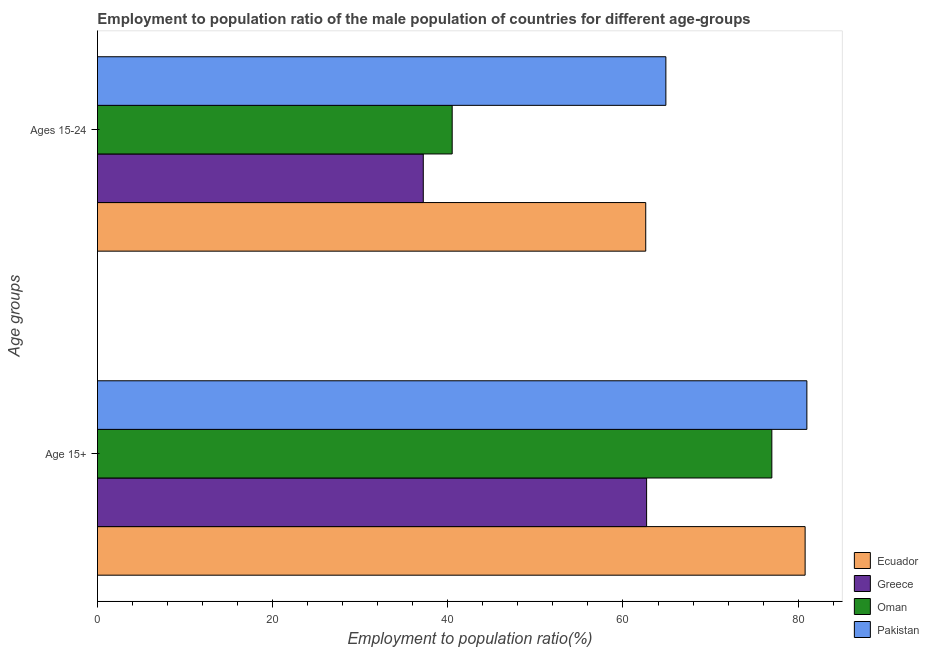Are the number of bars per tick equal to the number of legend labels?
Offer a very short reply. Yes. How many bars are there on the 1st tick from the top?
Ensure brevity in your answer.  4. How many bars are there on the 1st tick from the bottom?
Offer a terse response. 4. What is the label of the 2nd group of bars from the top?
Provide a short and direct response. Age 15+. What is the employment to population ratio(age 15+) in Greece?
Offer a very short reply. 62.7. Across all countries, what is the maximum employment to population ratio(age 15-24)?
Ensure brevity in your answer.  64.9. Across all countries, what is the minimum employment to population ratio(age 15-24)?
Make the answer very short. 37.2. In which country was the employment to population ratio(age 15-24) maximum?
Your answer should be very brief. Pakistan. In which country was the employment to population ratio(age 15+) minimum?
Offer a very short reply. Greece. What is the total employment to population ratio(age 15-24) in the graph?
Make the answer very short. 205.2. What is the difference between the employment to population ratio(age 15+) in Oman and that in Greece?
Your answer should be compact. 14.3. What is the difference between the employment to population ratio(age 15-24) in Ecuador and the employment to population ratio(age 15+) in Pakistan?
Your response must be concise. -18.4. What is the average employment to population ratio(age 15-24) per country?
Keep it short and to the point. 51.3. What is the difference between the employment to population ratio(age 15+) and employment to population ratio(age 15-24) in Oman?
Your answer should be very brief. 36.5. In how many countries, is the employment to population ratio(age 15+) greater than 40 %?
Offer a terse response. 4. What is the ratio of the employment to population ratio(age 15-24) in Ecuador to that in Greece?
Give a very brief answer. 1.68. Is the employment to population ratio(age 15+) in Oman less than that in Ecuador?
Offer a very short reply. Yes. In how many countries, is the employment to population ratio(age 15-24) greater than the average employment to population ratio(age 15-24) taken over all countries?
Offer a very short reply. 2. Are all the bars in the graph horizontal?
Your answer should be compact. Yes. How many countries are there in the graph?
Offer a terse response. 4. Are the values on the major ticks of X-axis written in scientific E-notation?
Your response must be concise. No. Does the graph contain any zero values?
Offer a terse response. No. Does the graph contain grids?
Your response must be concise. No. What is the title of the graph?
Your response must be concise. Employment to population ratio of the male population of countries for different age-groups. Does "High income: nonOECD" appear as one of the legend labels in the graph?
Offer a terse response. No. What is the label or title of the X-axis?
Give a very brief answer. Employment to population ratio(%). What is the label or title of the Y-axis?
Your answer should be very brief. Age groups. What is the Employment to population ratio(%) of Ecuador in Age 15+?
Ensure brevity in your answer.  80.8. What is the Employment to population ratio(%) in Greece in Age 15+?
Ensure brevity in your answer.  62.7. What is the Employment to population ratio(%) of Ecuador in Ages 15-24?
Give a very brief answer. 62.6. What is the Employment to population ratio(%) in Greece in Ages 15-24?
Provide a short and direct response. 37.2. What is the Employment to population ratio(%) in Oman in Ages 15-24?
Keep it short and to the point. 40.5. What is the Employment to population ratio(%) in Pakistan in Ages 15-24?
Provide a succinct answer. 64.9. Across all Age groups, what is the maximum Employment to population ratio(%) of Ecuador?
Keep it short and to the point. 80.8. Across all Age groups, what is the maximum Employment to population ratio(%) of Greece?
Your answer should be very brief. 62.7. Across all Age groups, what is the maximum Employment to population ratio(%) of Oman?
Provide a succinct answer. 77. Across all Age groups, what is the minimum Employment to population ratio(%) of Ecuador?
Your response must be concise. 62.6. Across all Age groups, what is the minimum Employment to population ratio(%) of Greece?
Your answer should be very brief. 37.2. Across all Age groups, what is the minimum Employment to population ratio(%) in Oman?
Give a very brief answer. 40.5. Across all Age groups, what is the minimum Employment to population ratio(%) of Pakistan?
Provide a short and direct response. 64.9. What is the total Employment to population ratio(%) of Ecuador in the graph?
Offer a terse response. 143.4. What is the total Employment to population ratio(%) in Greece in the graph?
Your answer should be very brief. 99.9. What is the total Employment to population ratio(%) of Oman in the graph?
Provide a short and direct response. 117.5. What is the total Employment to population ratio(%) of Pakistan in the graph?
Keep it short and to the point. 145.9. What is the difference between the Employment to population ratio(%) in Greece in Age 15+ and that in Ages 15-24?
Make the answer very short. 25.5. What is the difference between the Employment to population ratio(%) of Oman in Age 15+ and that in Ages 15-24?
Your answer should be very brief. 36.5. What is the difference between the Employment to population ratio(%) of Pakistan in Age 15+ and that in Ages 15-24?
Your answer should be compact. 16.1. What is the difference between the Employment to population ratio(%) in Ecuador in Age 15+ and the Employment to population ratio(%) in Greece in Ages 15-24?
Your answer should be very brief. 43.6. What is the difference between the Employment to population ratio(%) in Ecuador in Age 15+ and the Employment to population ratio(%) in Oman in Ages 15-24?
Keep it short and to the point. 40.3. What is the difference between the Employment to population ratio(%) in Greece in Age 15+ and the Employment to population ratio(%) in Oman in Ages 15-24?
Your answer should be very brief. 22.2. What is the difference between the Employment to population ratio(%) in Greece in Age 15+ and the Employment to population ratio(%) in Pakistan in Ages 15-24?
Make the answer very short. -2.2. What is the average Employment to population ratio(%) in Ecuador per Age groups?
Your answer should be compact. 71.7. What is the average Employment to population ratio(%) of Greece per Age groups?
Offer a very short reply. 49.95. What is the average Employment to population ratio(%) in Oman per Age groups?
Keep it short and to the point. 58.75. What is the average Employment to population ratio(%) in Pakistan per Age groups?
Keep it short and to the point. 72.95. What is the difference between the Employment to population ratio(%) of Ecuador and Employment to population ratio(%) of Pakistan in Age 15+?
Offer a terse response. -0.2. What is the difference between the Employment to population ratio(%) of Greece and Employment to population ratio(%) of Oman in Age 15+?
Your response must be concise. -14.3. What is the difference between the Employment to population ratio(%) in Greece and Employment to population ratio(%) in Pakistan in Age 15+?
Your response must be concise. -18.3. What is the difference between the Employment to population ratio(%) in Ecuador and Employment to population ratio(%) in Greece in Ages 15-24?
Your answer should be very brief. 25.4. What is the difference between the Employment to population ratio(%) in Ecuador and Employment to population ratio(%) in Oman in Ages 15-24?
Your answer should be compact. 22.1. What is the difference between the Employment to population ratio(%) of Greece and Employment to population ratio(%) of Pakistan in Ages 15-24?
Ensure brevity in your answer.  -27.7. What is the difference between the Employment to population ratio(%) of Oman and Employment to population ratio(%) of Pakistan in Ages 15-24?
Ensure brevity in your answer.  -24.4. What is the ratio of the Employment to population ratio(%) of Ecuador in Age 15+ to that in Ages 15-24?
Offer a very short reply. 1.29. What is the ratio of the Employment to population ratio(%) in Greece in Age 15+ to that in Ages 15-24?
Your answer should be very brief. 1.69. What is the ratio of the Employment to population ratio(%) of Oman in Age 15+ to that in Ages 15-24?
Ensure brevity in your answer.  1.9. What is the ratio of the Employment to population ratio(%) of Pakistan in Age 15+ to that in Ages 15-24?
Your response must be concise. 1.25. What is the difference between the highest and the second highest Employment to population ratio(%) in Oman?
Provide a short and direct response. 36.5. What is the difference between the highest and the lowest Employment to population ratio(%) in Oman?
Offer a very short reply. 36.5. 